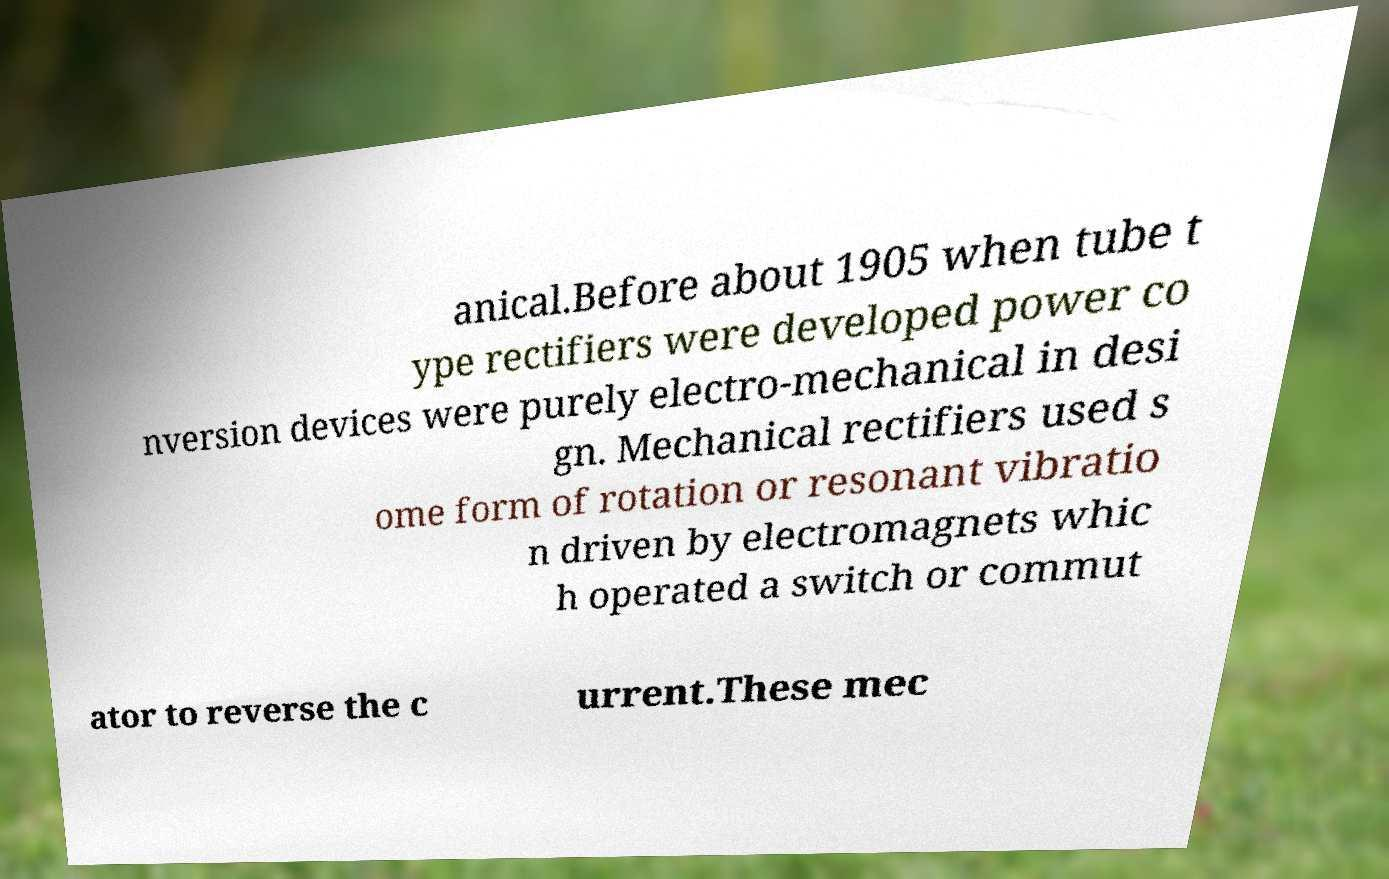There's text embedded in this image that I need extracted. Can you transcribe it verbatim? anical.Before about 1905 when tube t ype rectifiers were developed power co nversion devices were purely electro-mechanical in desi gn. Mechanical rectifiers used s ome form of rotation or resonant vibratio n driven by electromagnets whic h operated a switch or commut ator to reverse the c urrent.These mec 